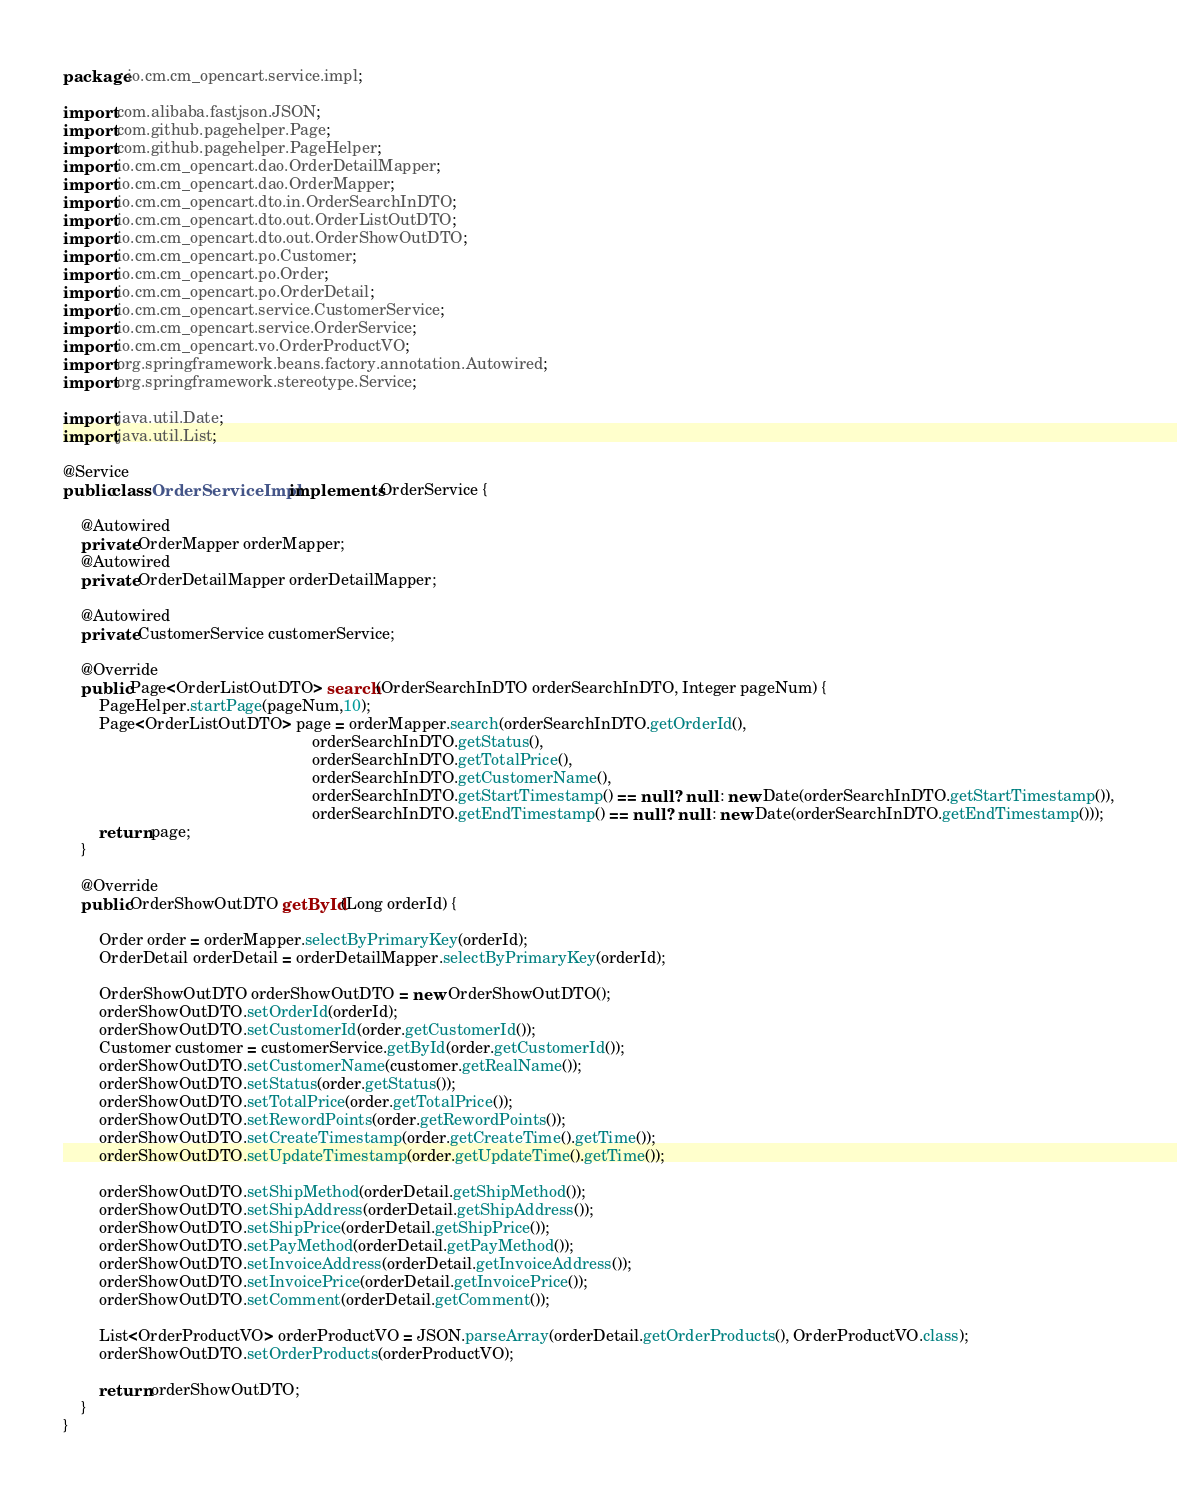<code> <loc_0><loc_0><loc_500><loc_500><_Java_>package io.cm.cm_opencart.service.impl;

import com.alibaba.fastjson.JSON;
import com.github.pagehelper.Page;
import com.github.pagehelper.PageHelper;
import io.cm.cm_opencart.dao.OrderDetailMapper;
import io.cm.cm_opencart.dao.OrderMapper;
import io.cm.cm_opencart.dto.in.OrderSearchInDTO;
import io.cm.cm_opencart.dto.out.OrderListOutDTO;
import io.cm.cm_opencart.dto.out.OrderShowOutDTO;
import io.cm.cm_opencart.po.Customer;
import io.cm.cm_opencart.po.Order;
import io.cm.cm_opencart.po.OrderDetail;
import io.cm.cm_opencart.service.CustomerService;
import io.cm.cm_opencart.service.OrderService;
import io.cm.cm_opencart.vo.OrderProductVO;
import org.springframework.beans.factory.annotation.Autowired;
import org.springframework.stereotype.Service;

import java.util.Date;
import java.util.List;

@Service
public class OrderServiceImpl implements OrderService {

    @Autowired
    private OrderMapper orderMapper;
    @Autowired
    private OrderDetailMapper orderDetailMapper;

    @Autowired
    private CustomerService customerService;

    @Override
    public Page<OrderListOutDTO> search(OrderSearchInDTO orderSearchInDTO, Integer pageNum) {
        PageHelper.startPage(pageNum,10);
        Page<OrderListOutDTO> page = orderMapper.search(orderSearchInDTO.getOrderId(),
                                                        orderSearchInDTO.getStatus(),
                                                        orderSearchInDTO.getTotalPrice(),
                                                        orderSearchInDTO.getCustomerName(),
                                                        orderSearchInDTO.getStartTimestamp() == null ? null : new Date(orderSearchInDTO.getStartTimestamp()),
                                                        orderSearchInDTO.getEndTimestamp() == null ? null : new Date(orderSearchInDTO.getEndTimestamp()));
        return page;
    }

    @Override
    public OrderShowOutDTO getById(Long orderId) {

        Order order = orderMapper.selectByPrimaryKey(orderId);
        OrderDetail orderDetail = orderDetailMapper.selectByPrimaryKey(orderId);

        OrderShowOutDTO orderShowOutDTO = new OrderShowOutDTO();
        orderShowOutDTO.setOrderId(orderId);
        orderShowOutDTO.setCustomerId(order.getCustomerId());
        Customer customer = customerService.getById(order.getCustomerId());
        orderShowOutDTO.setCustomerName(customer.getRealName());
        orderShowOutDTO.setStatus(order.getStatus());
        orderShowOutDTO.setTotalPrice(order.getTotalPrice());
        orderShowOutDTO.setRewordPoints(order.getRewordPoints());
        orderShowOutDTO.setCreateTimestamp(order.getCreateTime().getTime());
        orderShowOutDTO.setUpdateTimestamp(order.getUpdateTime().getTime());

        orderShowOutDTO.setShipMethod(orderDetail.getShipMethod());
        orderShowOutDTO.setShipAddress(orderDetail.getShipAddress());
        orderShowOutDTO.setShipPrice(orderDetail.getShipPrice());
        orderShowOutDTO.setPayMethod(orderDetail.getPayMethod());
        orderShowOutDTO.setInvoiceAddress(orderDetail.getInvoiceAddress());
        orderShowOutDTO.setInvoicePrice(orderDetail.getInvoicePrice());
        orderShowOutDTO.setComment(orderDetail.getComment());

        List<OrderProductVO> orderProductVO = JSON.parseArray(orderDetail.getOrderProducts(), OrderProductVO.class);
        orderShowOutDTO.setOrderProducts(orderProductVO);

        return orderShowOutDTO;
    }
}
</code> 